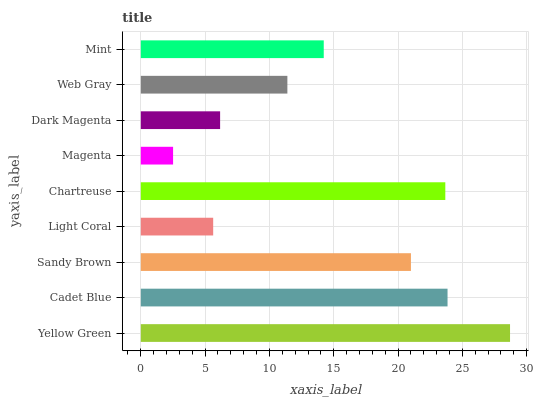Is Magenta the minimum?
Answer yes or no. Yes. Is Yellow Green the maximum?
Answer yes or no. Yes. Is Cadet Blue the minimum?
Answer yes or no. No. Is Cadet Blue the maximum?
Answer yes or no. No. Is Yellow Green greater than Cadet Blue?
Answer yes or no. Yes. Is Cadet Blue less than Yellow Green?
Answer yes or no. Yes. Is Cadet Blue greater than Yellow Green?
Answer yes or no. No. Is Yellow Green less than Cadet Blue?
Answer yes or no. No. Is Mint the high median?
Answer yes or no. Yes. Is Mint the low median?
Answer yes or no. Yes. Is Chartreuse the high median?
Answer yes or no. No. Is Yellow Green the low median?
Answer yes or no. No. 